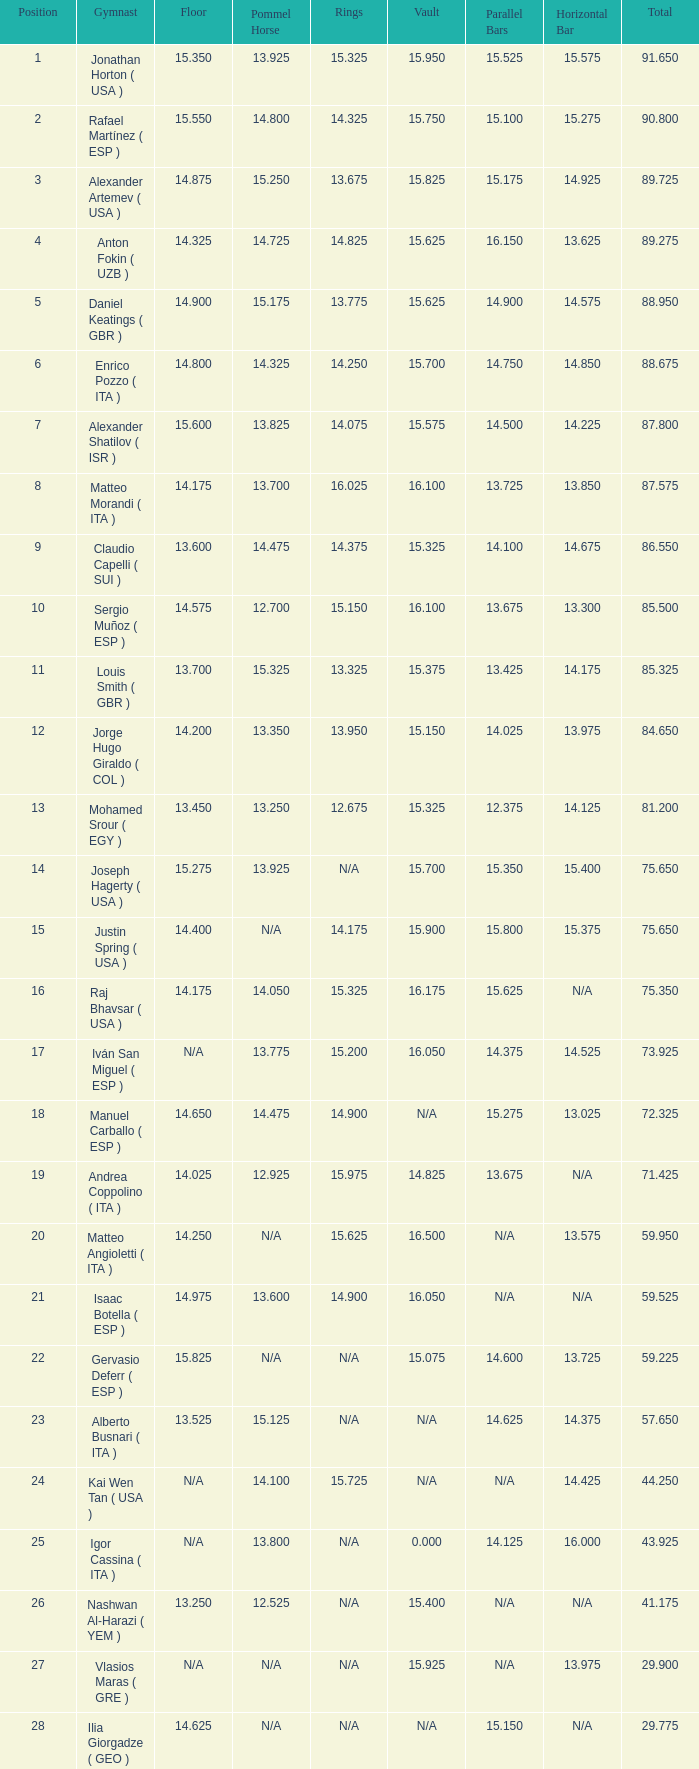If the parallel bars score is 1 Anton Fokin ( UZB ). 